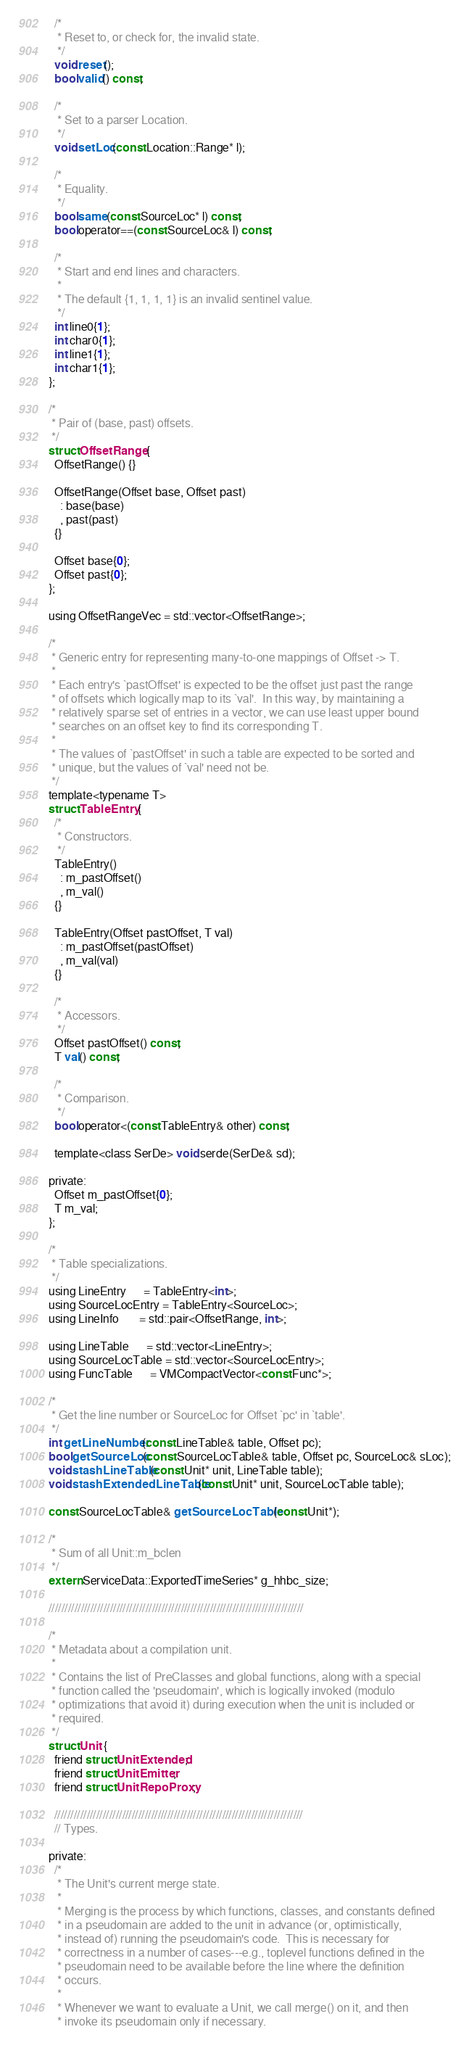<code> <loc_0><loc_0><loc_500><loc_500><_C_>  /*
   * Reset to, or check for, the invalid state.
   */
  void reset();
  bool valid() const;

  /*
   * Set to a parser Location.
   */
  void setLoc(const Location::Range* l);

  /*
   * Equality.
   */
  bool same(const SourceLoc* l) const;
  bool operator==(const SourceLoc& l) const;

  /*
   * Start and end lines and characters.
   *
   * The default {1, 1, 1, 1} is an invalid sentinel value.
   */
  int line0{1};
  int char0{1};
  int line1{1};
  int char1{1};
};

/*
 * Pair of (base, past) offsets.
 */
struct OffsetRange {
  OffsetRange() {}

  OffsetRange(Offset base, Offset past)
    : base(base)
    , past(past)
  {}

  Offset base{0};
  Offset past{0};
};

using OffsetRangeVec = std::vector<OffsetRange>;

/*
 * Generic entry for representing many-to-one mappings of Offset -> T.
 *
 * Each entry's `pastOffset' is expected to be the offset just past the range
 * of offsets which logically map to its `val'.  In this way, by maintaining a
 * relatively sparse set of entries in a vector, we can use least upper bound
 * searches on an offset key to find its corresponding T.
 *
 * The values of `pastOffset' in such a table are expected to be sorted and
 * unique, but the values of `val' need not be.
 */
template<typename T>
struct TableEntry {
  /*
   * Constructors.
   */
  TableEntry()
    : m_pastOffset()
    , m_val()
  {}

  TableEntry(Offset pastOffset, T val)
    : m_pastOffset(pastOffset)
    , m_val(val)
  {}

  /*
   * Accessors.
   */
  Offset pastOffset() const;
  T val() const;

  /*
   * Comparison.
   */
  bool operator<(const TableEntry& other) const;

  template<class SerDe> void serde(SerDe& sd);

private:
  Offset m_pastOffset{0};
  T m_val;
};

/*
 * Table specializations.
 */
using LineEntry      = TableEntry<int>;
using SourceLocEntry = TableEntry<SourceLoc>;
using LineInfo       = std::pair<OffsetRange, int>;

using LineTable      = std::vector<LineEntry>;
using SourceLocTable = std::vector<SourceLocEntry>;
using FuncTable      = VMCompactVector<const Func*>;

/*
 * Get the line number or SourceLoc for Offset `pc' in `table'.
 */
int getLineNumber(const LineTable& table, Offset pc);
bool getSourceLoc(const SourceLocTable& table, Offset pc, SourceLoc& sLoc);
void stashLineTable(const Unit* unit, LineTable table);
void stashExtendedLineTable(const Unit* unit, SourceLocTable table);

const SourceLocTable& getSourceLocTable(const Unit*);

/*
 * Sum of all Unit::m_bclen
 */
extern ServiceData::ExportedTimeSeries* g_hhbc_size;

///////////////////////////////////////////////////////////////////////////////

/*
 * Metadata about a compilation unit.
 *
 * Contains the list of PreClasses and global functions, along with a special
 * function called the 'pseudomain', which is logically invoked (modulo
 * optimizations that avoid it) during execution when the unit is included or
 * required.
 */
struct Unit {
  friend struct UnitExtended;
  friend struct UnitEmitter;
  friend struct UnitRepoProxy;

  /////////////////////////////////////////////////////////////////////////////
  // Types.

private:
  /*
   * The Unit's current merge state.
   *
   * Merging is the process by which functions, classes, and constants defined
   * in a pseudomain are added to the unit in advance (or, optimistically,
   * instead of) running the pseudomain's code.  This is necessary for
   * correctness in a number of cases---e.g., toplevel functions defined in the
   * pseudomain need to be available before the line where the definition
   * occurs.
   *
   * Whenever we want to evaluate a Unit, we call merge() on it, and then
   * invoke its pseudomain only if necessary.</code> 